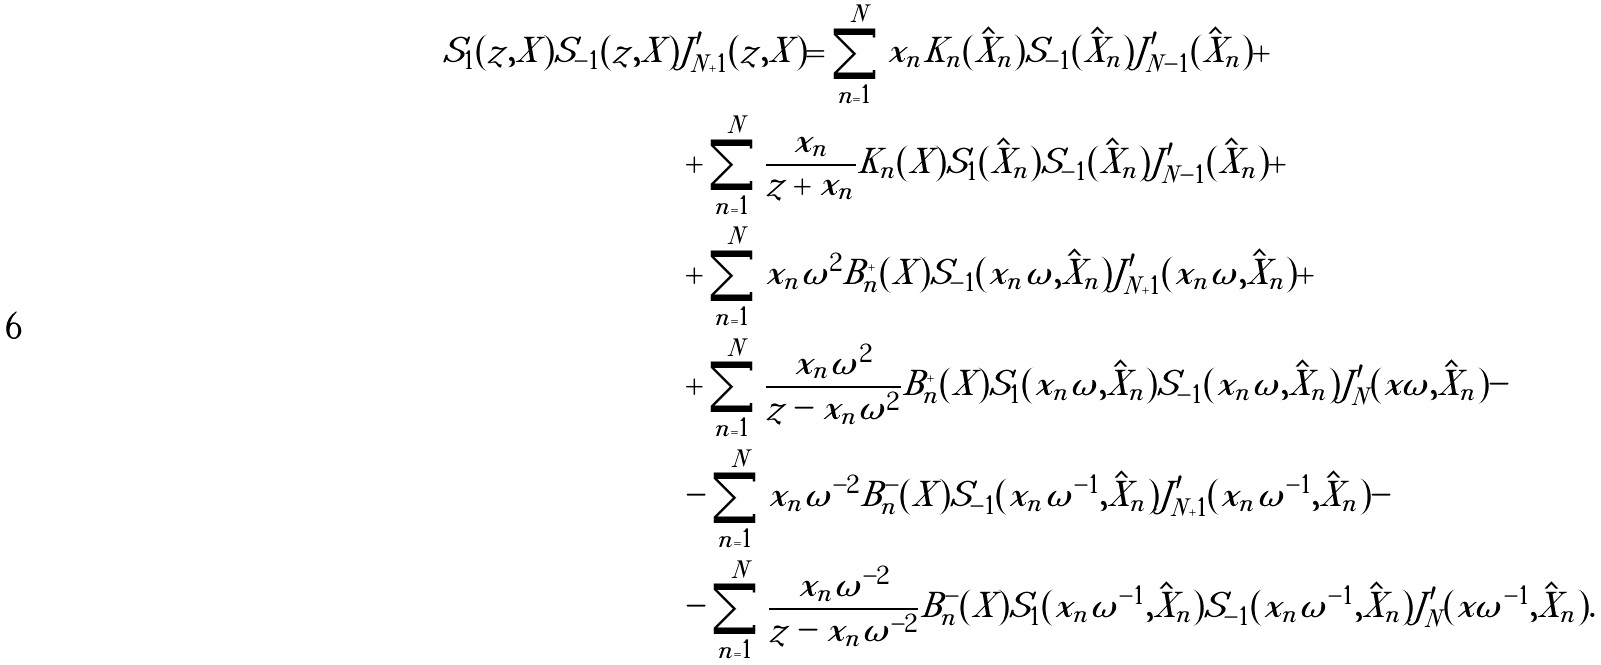<formula> <loc_0><loc_0><loc_500><loc_500>S _ { 1 } ( z , X ) S _ { - 1 } ( z , X ) & J ^ { \prime } _ { N + 1 } ( z , X ) = \sum _ { n = 1 } ^ { N } x _ { n } K _ { n } ( \hat { X } _ { n } ) S _ { - 1 } ( \hat { X } _ { n } ) J ^ { \prime } _ { N - 1 } ( \hat { X } _ { n } ) + \\ & + \sum _ { n = 1 } ^ { N } \frac { x _ { n } } { z + x _ { n } } K _ { n } ( X ) S _ { 1 } ( \hat { X } _ { n } ) S _ { - 1 } ( \hat { X } _ { n } ) J ^ { \prime } _ { N - 1 } ( \hat { X } _ { n } ) + \\ & + \sum _ { n = 1 } ^ { N } x _ { n } \omega ^ { 2 } B ^ { + } _ { n } ( X ) S _ { - 1 } ( x _ { n } \omega , \hat { X } _ { n } ) J ^ { \prime } _ { N + 1 } ( x _ { n } \omega , \hat { X } _ { n } ) + \\ & + \sum _ { n = 1 } ^ { N } \frac { x _ { n } \omega ^ { 2 } } { z - x _ { n } \omega ^ { 2 } } B ^ { + } _ { n } ( X ) S _ { 1 } ( x _ { n } \omega , \hat { X } _ { n } ) S _ { - 1 } ( x _ { n } \omega , \hat { X } _ { n } ) J ^ { \prime } _ { N } ( x \omega , \hat { X } _ { n } ) - \\ & - \sum _ { n = 1 } ^ { N } x _ { n } \omega ^ { - 2 } B ^ { - } _ { n } ( X ) S _ { - 1 } ( x _ { n } \omega ^ { - 1 } , \hat { X } _ { n } ) J ^ { \prime } _ { N + 1 } ( x _ { n } \omega ^ { - 1 } , \hat { X } _ { n } ) - \\ & - \sum _ { n = 1 } ^ { N } \frac { x _ { n } \omega ^ { - 2 } } { z - x _ { n } \omega ^ { - 2 } } B ^ { - } _ { n } ( X ) S _ { 1 } ( x _ { n } \omega ^ { - 1 } , \hat { X } _ { n } ) S _ { - 1 } ( x _ { n } \omega ^ { - 1 } , \hat { X } _ { n } ) J ^ { \prime } _ { N } ( x \omega ^ { - 1 } , \hat { X } _ { n } ) .</formula> 